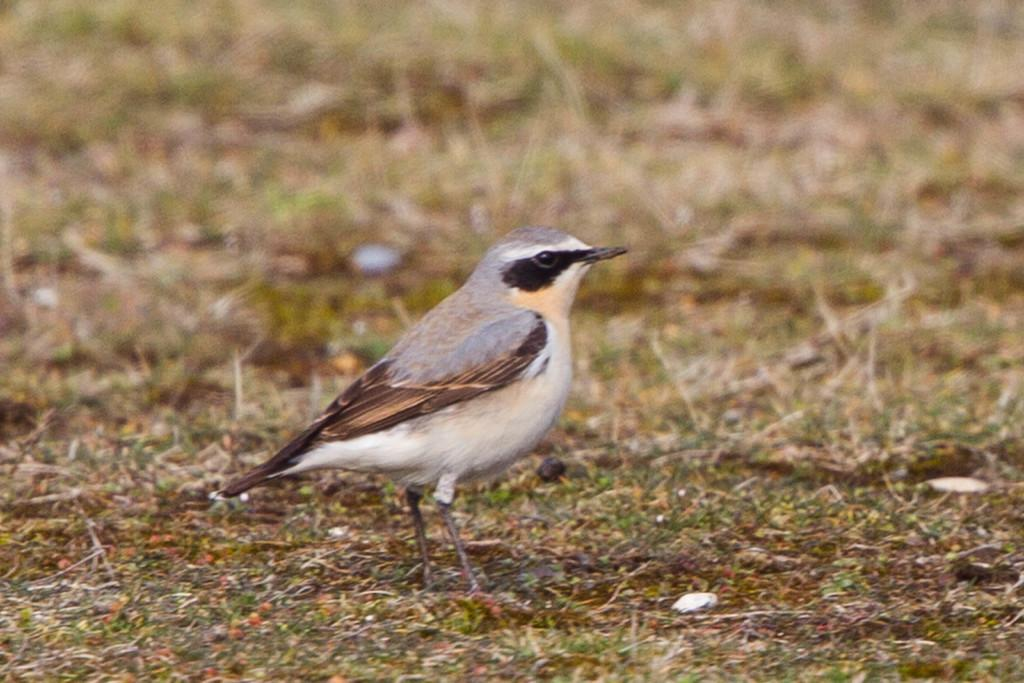What is the main subject of the image? There is a bird in the center of the image. Where is the bird located in the image? The bird is on the ground. What type of environment can be seen in the background of the image? There is grass visible in the background of the image. How is the bird measuring the distance to the cannon in the image? There is no cannon present in the image, and the bird is not measuring any distance. 